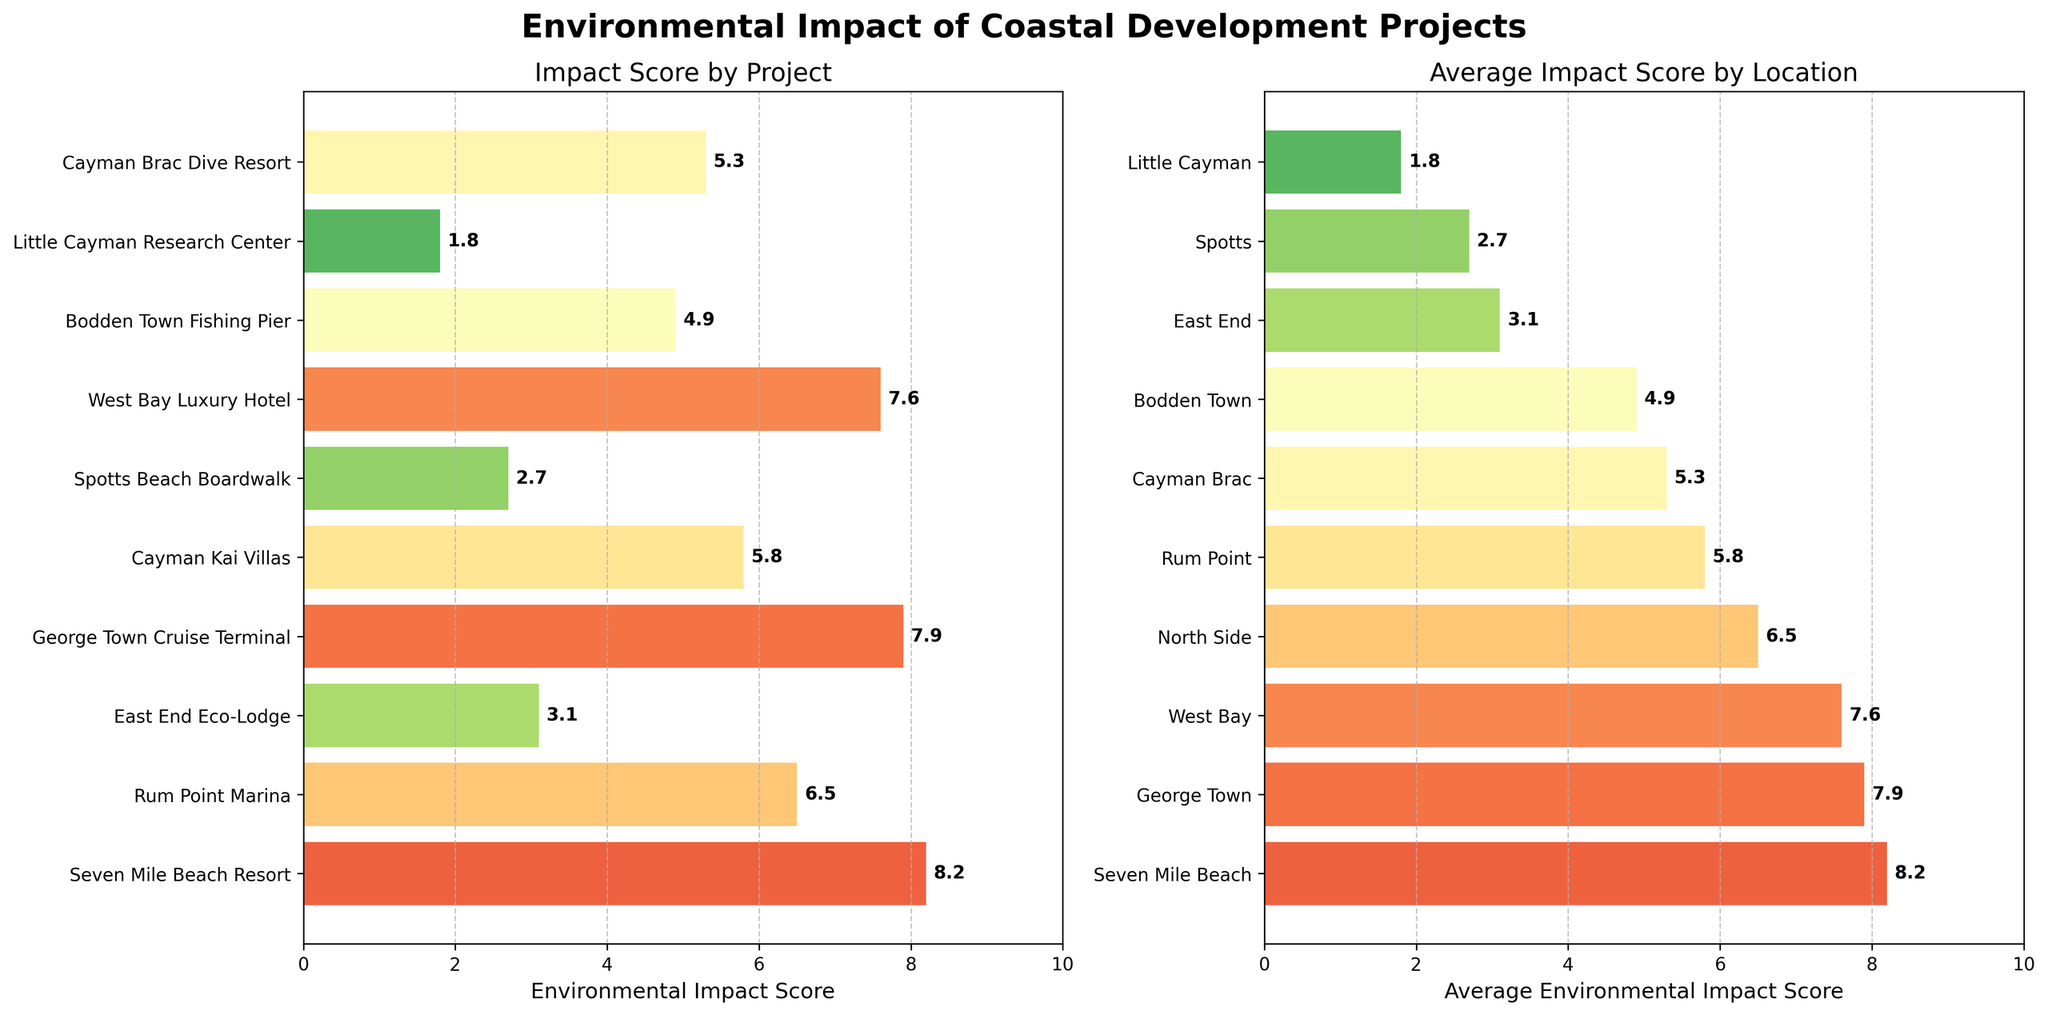What is the environmental impact score for the 'Seven Mile Beach Resort'? The score for each project is listed on the horizontal bars in the left subplot. The environmental impact score for 'Seven Mile Beach Resort' is labeled directly on its bar.
Answer: 8.2 What is the average environmental impact score for projects in 'George Town'? From the right subplot, we can see the average environmental impact score by location. Find 'George Town' and read the corresponding value.
Answer: 7.9 Which project has the lowest environmental impact score? In the left subplot, look for the shortest bar and read the project name next to it.
Answer: Little Cayman Research Center How many projects have an environmental impact score greater than 7? Count the number of bars in the left subplot that are longer than the 7 mark on the x-axis.
Answer: 3 Compare the environmental impact scores of 'West Bay Luxury Hotel' and 'George Town Cruise Terminal'. Which one is higher? Locate the bars for 'West Bay Luxury Hotel' and 'George Town Cruise Terminal' in the left subplot, and compare their lengths.
Answer: George Town Cruise Terminal What is the difference in the average environmental impact score between 'Rum Point' and 'East End'? Find the average scores for 'Rum Point' and 'East End' from the right subplot, then subtract the score of 'East End' from that of 'Rum Point'.
Answer: 2.7 (5.8 - 3.1) Which location has the highest average environmental impact score? In the right subplot, look for the longest horizontal bar and read the location name next to it.
Answer: George Town How many locations have an average environmental impact score below 6? In the right subplot, count the number of bars that are shorter than the 6 mark on the x-axis.
Answer: 6 What is the scale of the project with an environmental impact score of 5.3? Find the bar with a score of 5.3 in the left subplot, note the project name, and then refer to the data to find its scale.
Answer: Medium What is the average environmental impact score of all projects? Sum up all the environmental impact scores and divide by the number of projects. The scores are: 8.2 + 6.5 + 3.1 + 7.9 + 5.8 + 2.7 + 7.6 + 4.9 + 1.8 + 5.3 = 53.8. There are 10 projects. So, the average is 53.8 / 10.
Answer: 5.38 